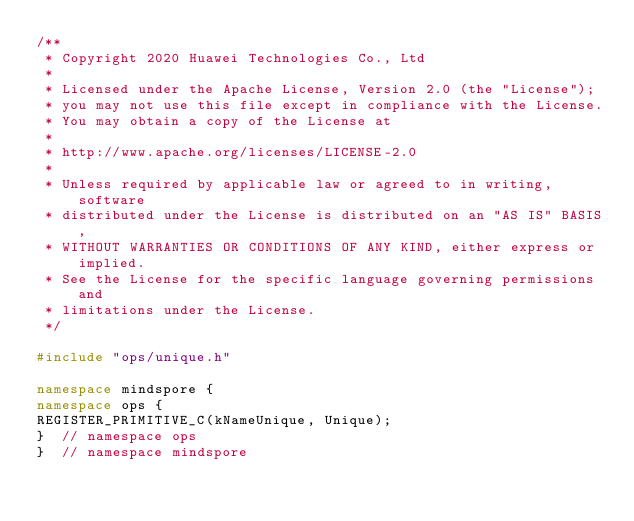<code> <loc_0><loc_0><loc_500><loc_500><_C++_>/**
 * Copyright 2020 Huawei Technologies Co., Ltd
 *
 * Licensed under the Apache License, Version 2.0 (the "License");
 * you may not use this file except in compliance with the License.
 * You may obtain a copy of the License at
 *
 * http://www.apache.org/licenses/LICENSE-2.0
 *
 * Unless required by applicable law or agreed to in writing, software
 * distributed under the License is distributed on an "AS IS" BASIS,
 * WITHOUT WARRANTIES OR CONDITIONS OF ANY KIND, either express or implied.
 * See the License for the specific language governing permissions and
 * limitations under the License.
 */

#include "ops/unique.h"

namespace mindspore {
namespace ops {
REGISTER_PRIMITIVE_C(kNameUnique, Unique);
}  // namespace ops
}  // namespace mindspore
</code> 